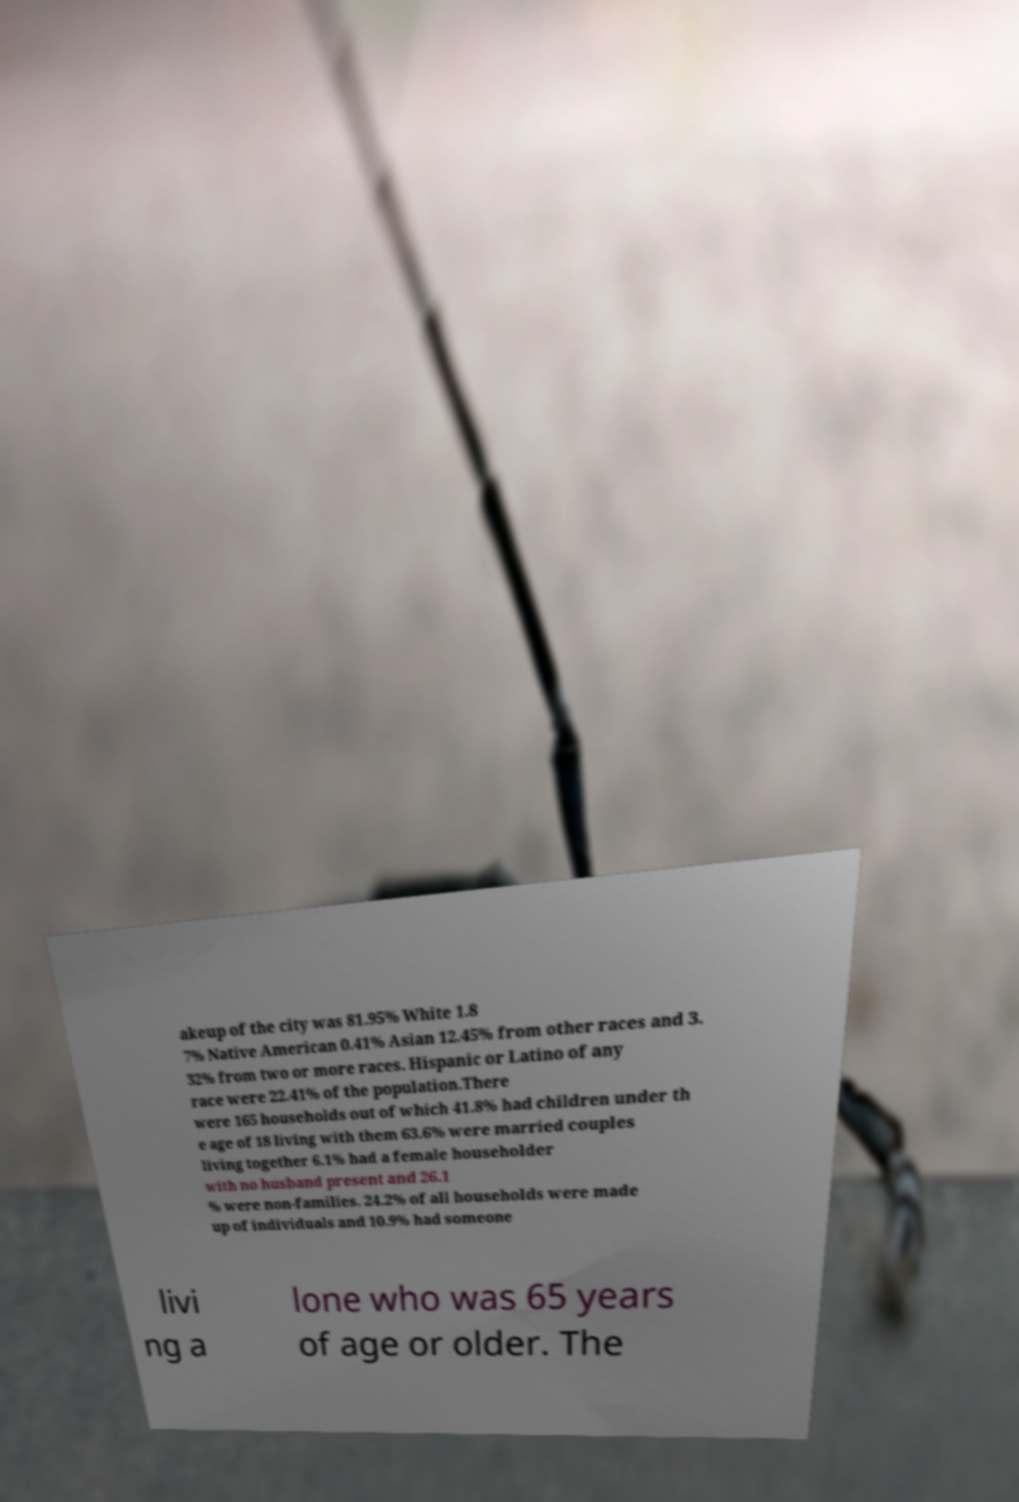Can you read and provide the text displayed in the image?This photo seems to have some interesting text. Can you extract and type it out for me? akeup of the city was 81.95% White 1.8 7% Native American 0.41% Asian 12.45% from other races and 3. 32% from two or more races. Hispanic or Latino of any race were 22.41% of the population.There were 165 households out of which 41.8% had children under th e age of 18 living with them 63.6% were married couples living together 6.1% had a female householder with no husband present and 26.1 % were non-families. 24.2% of all households were made up of individuals and 10.9% had someone livi ng a lone who was 65 years of age or older. The 